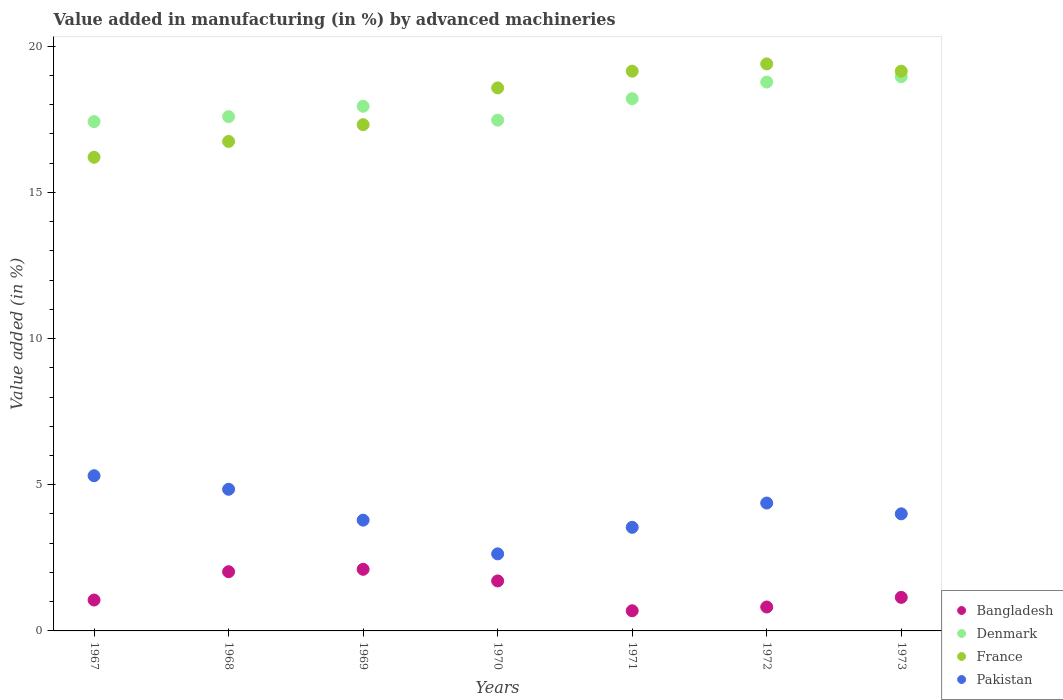How many different coloured dotlines are there?
Keep it short and to the point. 4. What is the percentage of value added in manufacturing by advanced machineries in France in 1968?
Offer a very short reply. 16.74. Across all years, what is the maximum percentage of value added in manufacturing by advanced machineries in Bangladesh?
Your response must be concise. 2.11. Across all years, what is the minimum percentage of value added in manufacturing by advanced machineries in France?
Offer a terse response. 16.2. In which year was the percentage of value added in manufacturing by advanced machineries in Bangladesh maximum?
Give a very brief answer. 1969. What is the total percentage of value added in manufacturing by advanced machineries in Pakistan in the graph?
Your response must be concise. 28.5. What is the difference between the percentage of value added in manufacturing by advanced machineries in Pakistan in 1968 and that in 1971?
Make the answer very short. 1.3. What is the difference between the percentage of value added in manufacturing by advanced machineries in Bangladesh in 1973 and the percentage of value added in manufacturing by advanced machineries in Denmark in 1971?
Your answer should be compact. -17.06. What is the average percentage of value added in manufacturing by advanced machineries in Bangladesh per year?
Your answer should be compact. 1.36. In the year 1972, what is the difference between the percentage of value added in manufacturing by advanced machineries in Bangladesh and percentage of value added in manufacturing by advanced machineries in Pakistan?
Make the answer very short. -3.56. In how many years, is the percentage of value added in manufacturing by advanced machineries in Pakistan greater than 19 %?
Your response must be concise. 0. What is the ratio of the percentage of value added in manufacturing by advanced machineries in Bangladesh in 1968 to that in 1973?
Provide a short and direct response. 1.77. Is the percentage of value added in manufacturing by advanced machineries in France in 1969 less than that in 1973?
Keep it short and to the point. Yes. What is the difference between the highest and the second highest percentage of value added in manufacturing by advanced machineries in Bangladesh?
Provide a succinct answer. 0.08. What is the difference between the highest and the lowest percentage of value added in manufacturing by advanced machineries in Denmark?
Make the answer very short. 1.54. Is the sum of the percentage of value added in manufacturing by advanced machineries in France in 1969 and 1972 greater than the maximum percentage of value added in manufacturing by advanced machineries in Bangladesh across all years?
Your answer should be very brief. Yes. Is it the case that in every year, the sum of the percentage of value added in manufacturing by advanced machineries in Denmark and percentage of value added in manufacturing by advanced machineries in France  is greater than the sum of percentage of value added in manufacturing by advanced machineries in Bangladesh and percentage of value added in manufacturing by advanced machineries in Pakistan?
Your response must be concise. Yes. Does the percentage of value added in manufacturing by advanced machineries in Denmark monotonically increase over the years?
Offer a terse response. No. Is the percentage of value added in manufacturing by advanced machineries in Denmark strictly greater than the percentage of value added in manufacturing by advanced machineries in Bangladesh over the years?
Keep it short and to the point. Yes. Is the percentage of value added in manufacturing by advanced machineries in Pakistan strictly less than the percentage of value added in manufacturing by advanced machineries in Denmark over the years?
Your response must be concise. Yes. How many years are there in the graph?
Your answer should be very brief. 7. What is the difference between two consecutive major ticks on the Y-axis?
Your response must be concise. 5. Are the values on the major ticks of Y-axis written in scientific E-notation?
Keep it short and to the point. No. Does the graph contain grids?
Offer a terse response. No. How many legend labels are there?
Offer a very short reply. 4. How are the legend labels stacked?
Offer a very short reply. Vertical. What is the title of the graph?
Offer a very short reply. Value added in manufacturing (in %) by advanced machineries. Does "Guinea-Bissau" appear as one of the legend labels in the graph?
Provide a succinct answer. No. What is the label or title of the X-axis?
Offer a terse response. Years. What is the label or title of the Y-axis?
Keep it short and to the point. Value added (in %). What is the Value added (in %) of Bangladesh in 1967?
Keep it short and to the point. 1.06. What is the Value added (in %) of Denmark in 1967?
Offer a very short reply. 17.42. What is the Value added (in %) in France in 1967?
Offer a very short reply. 16.2. What is the Value added (in %) of Pakistan in 1967?
Keep it short and to the point. 5.31. What is the Value added (in %) in Bangladesh in 1968?
Keep it short and to the point. 2.03. What is the Value added (in %) in Denmark in 1968?
Give a very brief answer. 17.59. What is the Value added (in %) in France in 1968?
Your answer should be compact. 16.74. What is the Value added (in %) in Pakistan in 1968?
Your response must be concise. 4.84. What is the Value added (in %) of Bangladesh in 1969?
Your answer should be very brief. 2.11. What is the Value added (in %) in Denmark in 1969?
Keep it short and to the point. 17.94. What is the Value added (in %) of France in 1969?
Your answer should be compact. 17.31. What is the Value added (in %) of Pakistan in 1969?
Keep it short and to the point. 3.79. What is the Value added (in %) of Bangladesh in 1970?
Your answer should be very brief. 1.71. What is the Value added (in %) of Denmark in 1970?
Provide a succinct answer. 17.47. What is the Value added (in %) of France in 1970?
Give a very brief answer. 18.57. What is the Value added (in %) in Pakistan in 1970?
Provide a short and direct response. 2.64. What is the Value added (in %) in Bangladesh in 1971?
Your answer should be compact. 0.69. What is the Value added (in %) in Denmark in 1971?
Give a very brief answer. 18.2. What is the Value added (in %) in France in 1971?
Give a very brief answer. 19.14. What is the Value added (in %) of Pakistan in 1971?
Your response must be concise. 3.54. What is the Value added (in %) of Bangladesh in 1972?
Your answer should be compact. 0.82. What is the Value added (in %) of Denmark in 1972?
Provide a short and direct response. 18.77. What is the Value added (in %) in France in 1972?
Offer a terse response. 19.39. What is the Value added (in %) of Pakistan in 1972?
Keep it short and to the point. 4.37. What is the Value added (in %) in Bangladesh in 1973?
Your answer should be compact. 1.15. What is the Value added (in %) of Denmark in 1973?
Your answer should be very brief. 18.95. What is the Value added (in %) of France in 1973?
Give a very brief answer. 19.14. What is the Value added (in %) of Pakistan in 1973?
Make the answer very short. 4. Across all years, what is the maximum Value added (in %) in Bangladesh?
Give a very brief answer. 2.11. Across all years, what is the maximum Value added (in %) of Denmark?
Offer a terse response. 18.95. Across all years, what is the maximum Value added (in %) of France?
Your answer should be very brief. 19.39. Across all years, what is the maximum Value added (in %) in Pakistan?
Keep it short and to the point. 5.31. Across all years, what is the minimum Value added (in %) of Bangladesh?
Ensure brevity in your answer.  0.69. Across all years, what is the minimum Value added (in %) in Denmark?
Offer a terse response. 17.42. Across all years, what is the minimum Value added (in %) of France?
Offer a very short reply. 16.2. Across all years, what is the minimum Value added (in %) of Pakistan?
Your answer should be compact. 2.64. What is the total Value added (in %) of Bangladesh in the graph?
Your answer should be very brief. 9.55. What is the total Value added (in %) of Denmark in the graph?
Keep it short and to the point. 126.35. What is the total Value added (in %) of France in the graph?
Your answer should be compact. 126.5. What is the total Value added (in %) of Pakistan in the graph?
Keep it short and to the point. 28.5. What is the difference between the Value added (in %) in Bangladesh in 1967 and that in 1968?
Your answer should be very brief. -0.97. What is the difference between the Value added (in %) in Denmark in 1967 and that in 1968?
Your answer should be compact. -0.17. What is the difference between the Value added (in %) in France in 1967 and that in 1968?
Your answer should be very brief. -0.54. What is the difference between the Value added (in %) in Pakistan in 1967 and that in 1968?
Offer a very short reply. 0.46. What is the difference between the Value added (in %) in Bangladesh in 1967 and that in 1969?
Your answer should be very brief. -1.05. What is the difference between the Value added (in %) of Denmark in 1967 and that in 1969?
Make the answer very short. -0.52. What is the difference between the Value added (in %) in France in 1967 and that in 1969?
Make the answer very short. -1.11. What is the difference between the Value added (in %) of Pakistan in 1967 and that in 1969?
Your answer should be very brief. 1.52. What is the difference between the Value added (in %) of Bangladesh in 1967 and that in 1970?
Your answer should be very brief. -0.65. What is the difference between the Value added (in %) of Denmark in 1967 and that in 1970?
Ensure brevity in your answer.  -0.05. What is the difference between the Value added (in %) of France in 1967 and that in 1970?
Your answer should be compact. -2.37. What is the difference between the Value added (in %) of Pakistan in 1967 and that in 1970?
Ensure brevity in your answer.  2.67. What is the difference between the Value added (in %) in Bangladesh in 1967 and that in 1971?
Make the answer very short. 0.37. What is the difference between the Value added (in %) of Denmark in 1967 and that in 1971?
Make the answer very short. -0.78. What is the difference between the Value added (in %) of France in 1967 and that in 1971?
Your answer should be compact. -2.94. What is the difference between the Value added (in %) in Pakistan in 1967 and that in 1971?
Offer a very short reply. 1.77. What is the difference between the Value added (in %) of Bangladesh in 1967 and that in 1972?
Provide a succinct answer. 0.24. What is the difference between the Value added (in %) of Denmark in 1967 and that in 1972?
Ensure brevity in your answer.  -1.35. What is the difference between the Value added (in %) in France in 1967 and that in 1972?
Ensure brevity in your answer.  -3.19. What is the difference between the Value added (in %) in Pakistan in 1967 and that in 1972?
Ensure brevity in your answer.  0.93. What is the difference between the Value added (in %) in Bangladesh in 1967 and that in 1973?
Your answer should be compact. -0.09. What is the difference between the Value added (in %) of Denmark in 1967 and that in 1973?
Offer a very short reply. -1.54. What is the difference between the Value added (in %) in France in 1967 and that in 1973?
Provide a succinct answer. -2.94. What is the difference between the Value added (in %) in Pakistan in 1967 and that in 1973?
Keep it short and to the point. 1.3. What is the difference between the Value added (in %) of Bangladesh in 1968 and that in 1969?
Your answer should be very brief. -0.08. What is the difference between the Value added (in %) of Denmark in 1968 and that in 1969?
Your answer should be compact. -0.35. What is the difference between the Value added (in %) of France in 1968 and that in 1969?
Give a very brief answer. -0.57. What is the difference between the Value added (in %) in Pakistan in 1968 and that in 1969?
Make the answer very short. 1.06. What is the difference between the Value added (in %) of Bangladesh in 1968 and that in 1970?
Provide a short and direct response. 0.32. What is the difference between the Value added (in %) in Denmark in 1968 and that in 1970?
Your answer should be compact. 0.12. What is the difference between the Value added (in %) of France in 1968 and that in 1970?
Your answer should be very brief. -1.83. What is the difference between the Value added (in %) in Pakistan in 1968 and that in 1970?
Provide a succinct answer. 2.21. What is the difference between the Value added (in %) in Bangladesh in 1968 and that in 1971?
Your answer should be compact. 1.34. What is the difference between the Value added (in %) of Denmark in 1968 and that in 1971?
Provide a short and direct response. -0.61. What is the difference between the Value added (in %) of France in 1968 and that in 1971?
Offer a very short reply. -2.4. What is the difference between the Value added (in %) of Pakistan in 1968 and that in 1971?
Your response must be concise. 1.3. What is the difference between the Value added (in %) in Bangladesh in 1968 and that in 1972?
Your response must be concise. 1.21. What is the difference between the Value added (in %) in Denmark in 1968 and that in 1972?
Your answer should be compact. -1.18. What is the difference between the Value added (in %) of France in 1968 and that in 1972?
Your response must be concise. -2.65. What is the difference between the Value added (in %) of Pakistan in 1968 and that in 1972?
Your answer should be compact. 0.47. What is the difference between the Value added (in %) of Bangladesh in 1968 and that in 1973?
Your answer should be very brief. 0.88. What is the difference between the Value added (in %) in Denmark in 1968 and that in 1973?
Your answer should be very brief. -1.37. What is the difference between the Value added (in %) of France in 1968 and that in 1973?
Provide a short and direct response. -2.4. What is the difference between the Value added (in %) in Pakistan in 1968 and that in 1973?
Your response must be concise. 0.84. What is the difference between the Value added (in %) in Bangladesh in 1969 and that in 1970?
Your response must be concise. 0.4. What is the difference between the Value added (in %) of Denmark in 1969 and that in 1970?
Provide a succinct answer. 0.47. What is the difference between the Value added (in %) in France in 1969 and that in 1970?
Ensure brevity in your answer.  -1.26. What is the difference between the Value added (in %) in Pakistan in 1969 and that in 1970?
Your answer should be compact. 1.15. What is the difference between the Value added (in %) of Bangladesh in 1969 and that in 1971?
Make the answer very short. 1.42. What is the difference between the Value added (in %) of Denmark in 1969 and that in 1971?
Your response must be concise. -0.26. What is the difference between the Value added (in %) in France in 1969 and that in 1971?
Your answer should be very brief. -1.83. What is the difference between the Value added (in %) of Pakistan in 1969 and that in 1971?
Offer a terse response. 0.25. What is the difference between the Value added (in %) in Bangladesh in 1969 and that in 1972?
Your answer should be compact. 1.29. What is the difference between the Value added (in %) in Denmark in 1969 and that in 1972?
Your answer should be very brief. -0.83. What is the difference between the Value added (in %) in France in 1969 and that in 1972?
Your answer should be compact. -2.08. What is the difference between the Value added (in %) of Pakistan in 1969 and that in 1972?
Your response must be concise. -0.58. What is the difference between the Value added (in %) of Bangladesh in 1969 and that in 1973?
Offer a very short reply. 0.96. What is the difference between the Value added (in %) in Denmark in 1969 and that in 1973?
Provide a short and direct response. -1.01. What is the difference between the Value added (in %) in France in 1969 and that in 1973?
Your response must be concise. -1.83. What is the difference between the Value added (in %) of Pakistan in 1969 and that in 1973?
Keep it short and to the point. -0.22. What is the difference between the Value added (in %) of Bangladesh in 1970 and that in 1971?
Ensure brevity in your answer.  1.02. What is the difference between the Value added (in %) of Denmark in 1970 and that in 1971?
Make the answer very short. -0.73. What is the difference between the Value added (in %) in France in 1970 and that in 1971?
Keep it short and to the point. -0.57. What is the difference between the Value added (in %) of Pakistan in 1970 and that in 1971?
Offer a very short reply. -0.91. What is the difference between the Value added (in %) of Bangladesh in 1970 and that in 1972?
Offer a terse response. 0.89. What is the difference between the Value added (in %) in Denmark in 1970 and that in 1972?
Your answer should be very brief. -1.3. What is the difference between the Value added (in %) in France in 1970 and that in 1972?
Ensure brevity in your answer.  -0.82. What is the difference between the Value added (in %) in Pakistan in 1970 and that in 1972?
Make the answer very short. -1.74. What is the difference between the Value added (in %) of Bangladesh in 1970 and that in 1973?
Provide a short and direct response. 0.56. What is the difference between the Value added (in %) of Denmark in 1970 and that in 1973?
Offer a very short reply. -1.48. What is the difference between the Value added (in %) in France in 1970 and that in 1973?
Give a very brief answer. -0.57. What is the difference between the Value added (in %) in Pakistan in 1970 and that in 1973?
Your response must be concise. -1.37. What is the difference between the Value added (in %) in Bangladesh in 1971 and that in 1972?
Make the answer very short. -0.13. What is the difference between the Value added (in %) of Denmark in 1971 and that in 1972?
Provide a short and direct response. -0.57. What is the difference between the Value added (in %) of France in 1971 and that in 1972?
Offer a very short reply. -0.25. What is the difference between the Value added (in %) of Pakistan in 1971 and that in 1972?
Provide a succinct answer. -0.83. What is the difference between the Value added (in %) of Bangladesh in 1971 and that in 1973?
Keep it short and to the point. -0.46. What is the difference between the Value added (in %) in Denmark in 1971 and that in 1973?
Offer a very short reply. -0.75. What is the difference between the Value added (in %) of France in 1971 and that in 1973?
Keep it short and to the point. -0. What is the difference between the Value added (in %) in Pakistan in 1971 and that in 1973?
Provide a succinct answer. -0.46. What is the difference between the Value added (in %) in Bangladesh in 1972 and that in 1973?
Provide a short and direct response. -0.33. What is the difference between the Value added (in %) in Denmark in 1972 and that in 1973?
Your answer should be very brief. -0.18. What is the difference between the Value added (in %) in France in 1972 and that in 1973?
Offer a terse response. 0.25. What is the difference between the Value added (in %) of Pakistan in 1972 and that in 1973?
Provide a succinct answer. 0.37. What is the difference between the Value added (in %) of Bangladesh in 1967 and the Value added (in %) of Denmark in 1968?
Your answer should be compact. -16.53. What is the difference between the Value added (in %) of Bangladesh in 1967 and the Value added (in %) of France in 1968?
Give a very brief answer. -15.68. What is the difference between the Value added (in %) in Bangladesh in 1967 and the Value added (in %) in Pakistan in 1968?
Your answer should be very brief. -3.79. What is the difference between the Value added (in %) in Denmark in 1967 and the Value added (in %) in France in 1968?
Keep it short and to the point. 0.68. What is the difference between the Value added (in %) of Denmark in 1967 and the Value added (in %) of Pakistan in 1968?
Ensure brevity in your answer.  12.57. What is the difference between the Value added (in %) of France in 1967 and the Value added (in %) of Pakistan in 1968?
Your response must be concise. 11.35. What is the difference between the Value added (in %) of Bangladesh in 1967 and the Value added (in %) of Denmark in 1969?
Ensure brevity in your answer.  -16.89. What is the difference between the Value added (in %) of Bangladesh in 1967 and the Value added (in %) of France in 1969?
Give a very brief answer. -16.26. What is the difference between the Value added (in %) in Bangladesh in 1967 and the Value added (in %) in Pakistan in 1969?
Provide a short and direct response. -2.73. What is the difference between the Value added (in %) in Denmark in 1967 and the Value added (in %) in France in 1969?
Provide a succinct answer. 0.1. What is the difference between the Value added (in %) in Denmark in 1967 and the Value added (in %) in Pakistan in 1969?
Your response must be concise. 13.63. What is the difference between the Value added (in %) in France in 1967 and the Value added (in %) in Pakistan in 1969?
Your response must be concise. 12.41. What is the difference between the Value added (in %) of Bangladesh in 1967 and the Value added (in %) of Denmark in 1970?
Ensure brevity in your answer.  -16.41. What is the difference between the Value added (in %) of Bangladesh in 1967 and the Value added (in %) of France in 1970?
Keep it short and to the point. -17.51. What is the difference between the Value added (in %) of Bangladesh in 1967 and the Value added (in %) of Pakistan in 1970?
Your answer should be compact. -1.58. What is the difference between the Value added (in %) of Denmark in 1967 and the Value added (in %) of France in 1970?
Your response must be concise. -1.15. What is the difference between the Value added (in %) in Denmark in 1967 and the Value added (in %) in Pakistan in 1970?
Your response must be concise. 14.78. What is the difference between the Value added (in %) of France in 1967 and the Value added (in %) of Pakistan in 1970?
Provide a short and direct response. 13.56. What is the difference between the Value added (in %) of Bangladesh in 1967 and the Value added (in %) of Denmark in 1971?
Provide a short and direct response. -17.15. What is the difference between the Value added (in %) in Bangladesh in 1967 and the Value added (in %) in France in 1971?
Your answer should be very brief. -18.09. What is the difference between the Value added (in %) in Bangladesh in 1967 and the Value added (in %) in Pakistan in 1971?
Offer a very short reply. -2.49. What is the difference between the Value added (in %) of Denmark in 1967 and the Value added (in %) of France in 1971?
Keep it short and to the point. -1.72. What is the difference between the Value added (in %) in Denmark in 1967 and the Value added (in %) in Pakistan in 1971?
Keep it short and to the point. 13.88. What is the difference between the Value added (in %) of France in 1967 and the Value added (in %) of Pakistan in 1971?
Your answer should be compact. 12.66. What is the difference between the Value added (in %) of Bangladesh in 1967 and the Value added (in %) of Denmark in 1972?
Your answer should be very brief. -17.71. What is the difference between the Value added (in %) of Bangladesh in 1967 and the Value added (in %) of France in 1972?
Make the answer very short. -18.34. What is the difference between the Value added (in %) in Bangladesh in 1967 and the Value added (in %) in Pakistan in 1972?
Offer a terse response. -3.32. What is the difference between the Value added (in %) in Denmark in 1967 and the Value added (in %) in France in 1972?
Keep it short and to the point. -1.97. What is the difference between the Value added (in %) of Denmark in 1967 and the Value added (in %) of Pakistan in 1972?
Your answer should be very brief. 13.05. What is the difference between the Value added (in %) of France in 1967 and the Value added (in %) of Pakistan in 1972?
Give a very brief answer. 11.83. What is the difference between the Value added (in %) in Bangladesh in 1967 and the Value added (in %) in Denmark in 1973?
Offer a very short reply. -17.9. What is the difference between the Value added (in %) of Bangladesh in 1967 and the Value added (in %) of France in 1973?
Your response must be concise. -18.09. What is the difference between the Value added (in %) in Bangladesh in 1967 and the Value added (in %) in Pakistan in 1973?
Make the answer very short. -2.95. What is the difference between the Value added (in %) of Denmark in 1967 and the Value added (in %) of France in 1973?
Provide a succinct answer. -1.72. What is the difference between the Value added (in %) of Denmark in 1967 and the Value added (in %) of Pakistan in 1973?
Your response must be concise. 13.41. What is the difference between the Value added (in %) in France in 1967 and the Value added (in %) in Pakistan in 1973?
Ensure brevity in your answer.  12.19. What is the difference between the Value added (in %) in Bangladesh in 1968 and the Value added (in %) in Denmark in 1969?
Keep it short and to the point. -15.92. What is the difference between the Value added (in %) in Bangladesh in 1968 and the Value added (in %) in France in 1969?
Offer a terse response. -15.29. What is the difference between the Value added (in %) in Bangladesh in 1968 and the Value added (in %) in Pakistan in 1969?
Give a very brief answer. -1.76. What is the difference between the Value added (in %) of Denmark in 1968 and the Value added (in %) of France in 1969?
Your answer should be compact. 0.27. What is the difference between the Value added (in %) in Denmark in 1968 and the Value added (in %) in Pakistan in 1969?
Your response must be concise. 13.8. What is the difference between the Value added (in %) in France in 1968 and the Value added (in %) in Pakistan in 1969?
Provide a short and direct response. 12.95. What is the difference between the Value added (in %) in Bangladesh in 1968 and the Value added (in %) in Denmark in 1970?
Give a very brief answer. -15.44. What is the difference between the Value added (in %) in Bangladesh in 1968 and the Value added (in %) in France in 1970?
Your answer should be compact. -16.55. What is the difference between the Value added (in %) in Bangladesh in 1968 and the Value added (in %) in Pakistan in 1970?
Your response must be concise. -0.61. What is the difference between the Value added (in %) in Denmark in 1968 and the Value added (in %) in France in 1970?
Provide a succinct answer. -0.98. What is the difference between the Value added (in %) in Denmark in 1968 and the Value added (in %) in Pakistan in 1970?
Provide a succinct answer. 14.95. What is the difference between the Value added (in %) of France in 1968 and the Value added (in %) of Pakistan in 1970?
Provide a short and direct response. 14.11. What is the difference between the Value added (in %) in Bangladesh in 1968 and the Value added (in %) in Denmark in 1971?
Your answer should be very brief. -16.18. What is the difference between the Value added (in %) in Bangladesh in 1968 and the Value added (in %) in France in 1971?
Provide a succinct answer. -17.12. What is the difference between the Value added (in %) in Bangladesh in 1968 and the Value added (in %) in Pakistan in 1971?
Provide a succinct answer. -1.52. What is the difference between the Value added (in %) in Denmark in 1968 and the Value added (in %) in France in 1971?
Keep it short and to the point. -1.56. What is the difference between the Value added (in %) of Denmark in 1968 and the Value added (in %) of Pakistan in 1971?
Your answer should be very brief. 14.05. What is the difference between the Value added (in %) in France in 1968 and the Value added (in %) in Pakistan in 1971?
Your answer should be very brief. 13.2. What is the difference between the Value added (in %) in Bangladesh in 1968 and the Value added (in %) in Denmark in 1972?
Give a very brief answer. -16.75. What is the difference between the Value added (in %) in Bangladesh in 1968 and the Value added (in %) in France in 1972?
Keep it short and to the point. -17.37. What is the difference between the Value added (in %) in Bangladesh in 1968 and the Value added (in %) in Pakistan in 1972?
Your answer should be very brief. -2.35. What is the difference between the Value added (in %) of Denmark in 1968 and the Value added (in %) of France in 1972?
Offer a very short reply. -1.8. What is the difference between the Value added (in %) of Denmark in 1968 and the Value added (in %) of Pakistan in 1972?
Provide a short and direct response. 13.21. What is the difference between the Value added (in %) of France in 1968 and the Value added (in %) of Pakistan in 1972?
Provide a succinct answer. 12.37. What is the difference between the Value added (in %) in Bangladesh in 1968 and the Value added (in %) in Denmark in 1973?
Make the answer very short. -16.93. What is the difference between the Value added (in %) in Bangladesh in 1968 and the Value added (in %) in France in 1973?
Your answer should be compact. -17.12. What is the difference between the Value added (in %) of Bangladesh in 1968 and the Value added (in %) of Pakistan in 1973?
Your response must be concise. -1.98. What is the difference between the Value added (in %) of Denmark in 1968 and the Value added (in %) of France in 1973?
Your answer should be very brief. -1.56. What is the difference between the Value added (in %) of Denmark in 1968 and the Value added (in %) of Pakistan in 1973?
Provide a succinct answer. 13.58. What is the difference between the Value added (in %) in France in 1968 and the Value added (in %) in Pakistan in 1973?
Ensure brevity in your answer.  12.74. What is the difference between the Value added (in %) in Bangladesh in 1969 and the Value added (in %) in Denmark in 1970?
Provide a short and direct response. -15.36. What is the difference between the Value added (in %) in Bangladesh in 1969 and the Value added (in %) in France in 1970?
Provide a succinct answer. -16.46. What is the difference between the Value added (in %) in Bangladesh in 1969 and the Value added (in %) in Pakistan in 1970?
Your answer should be very brief. -0.53. What is the difference between the Value added (in %) of Denmark in 1969 and the Value added (in %) of France in 1970?
Offer a very short reply. -0.63. What is the difference between the Value added (in %) of Denmark in 1969 and the Value added (in %) of Pakistan in 1970?
Provide a short and direct response. 15.31. What is the difference between the Value added (in %) in France in 1969 and the Value added (in %) in Pakistan in 1970?
Offer a very short reply. 14.68. What is the difference between the Value added (in %) of Bangladesh in 1969 and the Value added (in %) of Denmark in 1971?
Offer a terse response. -16.1. What is the difference between the Value added (in %) in Bangladesh in 1969 and the Value added (in %) in France in 1971?
Ensure brevity in your answer.  -17.04. What is the difference between the Value added (in %) of Bangladesh in 1969 and the Value added (in %) of Pakistan in 1971?
Give a very brief answer. -1.44. What is the difference between the Value added (in %) in Denmark in 1969 and the Value added (in %) in France in 1971?
Offer a terse response. -1.2. What is the difference between the Value added (in %) in Denmark in 1969 and the Value added (in %) in Pakistan in 1971?
Give a very brief answer. 14.4. What is the difference between the Value added (in %) in France in 1969 and the Value added (in %) in Pakistan in 1971?
Your answer should be compact. 13.77. What is the difference between the Value added (in %) of Bangladesh in 1969 and the Value added (in %) of Denmark in 1972?
Keep it short and to the point. -16.66. What is the difference between the Value added (in %) in Bangladesh in 1969 and the Value added (in %) in France in 1972?
Make the answer very short. -17.28. What is the difference between the Value added (in %) in Bangladesh in 1969 and the Value added (in %) in Pakistan in 1972?
Your response must be concise. -2.27. What is the difference between the Value added (in %) in Denmark in 1969 and the Value added (in %) in France in 1972?
Your answer should be very brief. -1.45. What is the difference between the Value added (in %) of Denmark in 1969 and the Value added (in %) of Pakistan in 1972?
Your response must be concise. 13.57. What is the difference between the Value added (in %) in France in 1969 and the Value added (in %) in Pakistan in 1972?
Your answer should be compact. 12.94. What is the difference between the Value added (in %) in Bangladesh in 1969 and the Value added (in %) in Denmark in 1973?
Provide a short and direct response. -16.85. What is the difference between the Value added (in %) of Bangladesh in 1969 and the Value added (in %) of France in 1973?
Provide a succinct answer. -17.04. What is the difference between the Value added (in %) in Bangladesh in 1969 and the Value added (in %) in Pakistan in 1973?
Provide a succinct answer. -1.9. What is the difference between the Value added (in %) of Denmark in 1969 and the Value added (in %) of France in 1973?
Ensure brevity in your answer.  -1.2. What is the difference between the Value added (in %) of Denmark in 1969 and the Value added (in %) of Pakistan in 1973?
Keep it short and to the point. 13.94. What is the difference between the Value added (in %) of France in 1969 and the Value added (in %) of Pakistan in 1973?
Your answer should be compact. 13.31. What is the difference between the Value added (in %) of Bangladesh in 1970 and the Value added (in %) of Denmark in 1971?
Make the answer very short. -16.49. What is the difference between the Value added (in %) of Bangladesh in 1970 and the Value added (in %) of France in 1971?
Keep it short and to the point. -17.43. What is the difference between the Value added (in %) in Bangladesh in 1970 and the Value added (in %) in Pakistan in 1971?
Your answer should be very brief. -1.83. What is the difference between the Value added (in %) of Denmark in 1970 and the Value added (in %) of France in 1971?
Provide a succinct answer. -1.67. What is the difference between the Value added (in %) in Denmark in 1970 and the Value added (in %) in Pakistan in 1971?
Keep it short and to the point. 13.93. What is the difference between the Value added (in %) in France in 1970 and the Value added (in %) in Pakistan in 1971?
Make the answer very short. 15.03. What is the difference between the Value added (in %) of Bangladesh in 1970 and the Value added (in %) of Denmark in 1972?
Offer a terse response. -17.06. What is the difference between the Value added (in %) in Bangladesh in 1970 and the Value added (in %) in France in 1972?
Your response must be concise. -17.68. What is the difference between the Value added (in %) of Bangladesh in 1970 and the Value added (in %) of Pakistan in 1972?
Make the answer very short. -2.66. What is the difference between the Value added (in %) in Denmark in 1970 and the Value added (in %) in France in 1972?
Provide a short and direct response. -1.92. What is the difference between the Value added (in %) of Denmark in 1970 and the Value added (in %) of Pakistan in 1972?
Your answer should be compact. 13.1. What is the difference between the Value added (in %) of France in 1970 and the Value added (in %) of Pakistan in 1972?
Keep it short and to the point. 14.2. What is the difference between the Value added (in %) in Bangladesh in 1970 and the Value added (in %) in Denmark in 1973?
Keep it short and to the point. -17.24. What is the difference between the Value added (in %) in Bangladesh in 1970 and the Value added (in %) in France in 1973?
Offer a terse response. -17.43. What is the difference between the Value added (in %) of Bangladesh in 1970 and the Value added (in %) of Pakistan in 1973?
Provide a short and direct response. -2.29. What is the difference between the Value added (in %) of Denmark in 1970 and the Value added (in %) of France in 1973?
Keep it short and to the point. -1.67. What is the difference between the Value added (in %) of Denmark in 1970 and the Value added (in %) of Pakistan in 1973?
Ensure brevity in your answer.  13.46. What is the difference between the Value added (in %) of France in 1970 and the Value added (in %) of Pakistan in 1973?
Provide a short and direct response. 14.57. What is the difference between the Value added (in %) of Bangladesh in 1971 and the Value added (in %) of Denmark in 1972?
Ensure brevity in your answer.  -18.08. What is the difference between the Value added (in %) in Bangladesh in 1971 and the Value added (in %) in France in 1972?
Give a very brief answer. -18.7. What is the difference between the Value added (in %) of Bangladesh in 1971 and the Value added (in %) of Pakistan in 1972?
Offer a terse response. -3.68. What is the difference between the Value added (in %) of Denmark in 1971 and the Value added (in %) of France in 1972?
Provide a short and direct response. -1.19. What is the difference between the Value added (in %) in Denmark in 1971 and the Value added (in %) in Pakistan in 1972?
Provide a succinct answer. 13.83. What is the difference between the Value added (in %) in France in 1971 and the Value added (in %) in Pakistan in 1972?
Offer a very short reply. 14.77. What is the difference between the Value added (in %) of Bangladesh in 1971 and the Value added (in %) of Denmark in 1973?
Keep it short and to the point. -18.27. What is the difference between the Value added (in %) in Bangladesh in 1971 and the Value added (in %) in France in 1973?
Your response must be concise. -18.45. What is the difference between the Value added (in %) in Bangladesh in 1971 and the Value added (in %) in Pakistan in 1973?
Provide a short and direct response. -3.32. What is the difference between the Value added (in %) in Denmark in 1971 and the Value added (in %) in France in 1973?
Keep it short and to the point. -0.94. What is the difference between the Value added (in %) of Denmark in 1971 and the Value added (in %) of Pakistan in 1973?
Provide a short and direct response. 14.2. What is the difference between the Value added (in %) of France in 1971 and the Value added (in %) of Pakistan in 1973?
Offer a terse response. 15.14. What is the difference between the Value added (in %) in Bangladesh in 1972 and the Value added (in %) in Denmark in 1973?
Keep it short and to the point. -18.14. What is the difference between the Value added (in %) in Bangladesh in 1972 and the Value added (in %) in France in 1973?
Your answer should be very brief. -18.33. What is the difference between the Value added (in %) of Bangladesh in 1972 and the Value added (in %) of Pakistan in 1973?
Provide a short and direct response. -3.19. What is the difference between the Value added (in %) of Denmark in 1972 and the Value added (in %) of France in 1973?
Provide a short and direct response. -0.37. What is the difference between the Value added (in %) in Denmark in 1972 and the Value added (in %) in Pakistan in 1973?
Keep it short and to the point. 14.77. What is the difference between the Value added (in %) of France in 1972 and the Value added (in %) of Pakistan in 1973?
Your answer should be very brief. 15.39. What is the average Value added (in %) in Bangladesh per year?
Your answer should be very brief. 1.36. What is the average Value added (in %) of Denmark per year?
Provide a succinct answer. 18.05. What is the average Value added (in %) in France per year?
Your answer should be very brief. 18.07. What is the average Value added (in %) of Pakistan per year?
Provide a short and direct response. 4.07. In the year 1967, what is the difference between the Value added (in %) of Bangladesh and Value added (in %) of Denmark?
Keep it short and to the point. -16.36. In the year 1967, what is the difference between the Value added (in %) of Bangladesh and Value added (in %) of France?
Keep it short and to the point. -15.14. In the year 1967, what is the difference between the Value added (in %) of Bangladesh and Value added (in %) of Pakistan?
Offer a very short reply. -4.25. In the year 1967, what is the difference between the Value added (in %) in Denmark and Value added (in %) in France?
Give a very brief answer. 1.22. In the year 1967, what is the difference between the Value added (in %) of Denmark and Value added (in %) of Pakistan?
Your response must be concise. 12.11. In the year 1967, what is the difference between the Value added (in %) in France and Value added (in %) in Pakistan?
Ensure brevity in your answer.  10.89. In the year 1968, what is the difference between the Value added (in %) in Bangladesh and Value added (in %) in Denmark?
Offer a very short reply. -15.56. In the year 1968, what is the difference between the Value added (in %) of Bangladesh and Value added (in %) of France?
Give a very brief answer. -14.72. In the year 1968, what is the difference between the Value added (in %) of Bangladesh and Value added (in %) of Pakistan?
Provide a succinct answer. -2.82. In the year 1968, what is the difference between the Value added (in %) in Denmark and Value added (in %) in France?
Make the answer very short. 0.85. In the year 1968, what is the difference between the Value added (in %) in Denmark and Value added (in %) in Pakistan?
Make the answer very short. 12.74. In the year 1968, what is the difference between the Value added (in %) in France and Value added (in %) in Pakistan?
Offer a very short reply. 11.9. In the year 1969, what is the difference between the Value added (in %) of Bangladesh and Value added (in %) of Denmark?
Provide a short and direct response. -15.84. In the year 1969, what is the difference between the Value added (in %) in Bangladesh and Value added (in %) in France?
Provide a short and direct response. -15.21. In the year 1969, what is the difference between the Value added (in %) in Bangladesh and Value added (in %) in Pakistan?
Your answer should be compact. -1.68. In the year 1969, what is the difference between the Value added (in %) in Denmark and Value added (in %) in France?
Give a very brief answer. 0.63. In the year 1969, what is the difference between the Value added (in %) of Denmark and Value added (in %) of Pakistan?
Offer a very short reply. 14.15. In the year 1969, what is the difference between the Value added (in %) of France and Value added (in %) of Pakistan?
Offer a terse response. 13.53. In the year 1970, what is the difference between the Value added (in %) of Bangladesh and Value added (in %) of Denmark?
Your response must be concise. -15.76. In the year 1970, what is the difference between the Value added (in %) of Bangladesh and Value added (in %) of France?
Your answer should be very brief. -16.86. In the year 1970, what is the difference between the Value added (in %) in Bangladesh and Value added (in %) in Pakistan?
Ensure brevity in your answer.  -0.93. In the year 1970, what is the difference between the Value added (in %) in Denmark and Value added (in %) in France?
Make the answer very short. -1.1. In the year 1970, what is the difference between the Value added (in %) in Denmark and Value added (in %) in Pakistan?
Keep it short and to the point. 14.83. In the year 1970, what is the difference between the Value added (in %) in France and Value added (in %) in Pakistan?
Offer a terse response. 15.94. In the year 1971, what is the difference between the Value added (in %) in Bangladesh and Value added (in %) in Denmark?
Give a very brief answer. -17.51. In the year 1971, what is the difference between the Value added (in %) in Bangladesh and Value added (in %) in France?
Ensure brevity in your answer.  -18.45. In the year 1971, what is the difference between the Value added (in %) in Bangladesh and Value added (in %) in Pakistan?
Your response must be concise. -2.85. In the year 1971, what is the difference between the Value added (in %) of Denmark and Value added (in %) of France?
Your answer should be very brief. -0.94. In the year 1971, what is the difference between the Value added (in %) in Denmark and Value added (in %) in Pakistan?
Offer a very short reply. 14.66. In the year 1971, what is the difference between the Value added (in %) of France and Value added (in %) of Pakistan?
Offer a very short reply. 15.6. In the year 1972, what is the difference between the Value added (in %) of Bangladesh and Value added (in %) of Denmark?
Offer a very short reply. -17.95. In the year 1972, what is the difference between the Value added (in %) of Bangladesh and Value added (in %) of France?
Your answer should be compact. -18.57. In the year 1972, what is the difference between the Value added (in %) of Bangladesh and Value added (in %) of Pakistan?
Offer a terse response. -3.56. In the year 1972, what is the difference between the Value added (in %) in Denmark and Value added (in %) in France?
Keep it short and to the point. -0.62. In the year 1972, what is the difference between the Value added (in %) in Denmark and Value added (in %) in Pakistan?
Provide a succinct answer. 14.4. In the year 1972, what is the difference between the Value added (in %) of France and Value added (in %) of Pakistan?
Keep it short and to the point. 15.02. In the year 1973, what is the difference between the Value added (in %) of Bangladesh and Value added (in %) of Denmark?
Provide a short and direct response. -17.81. In the year 1973, what is the difference between the Value added (in %) in Bangladesh and Value added (in %) in France?
Your answer should be very brief. -18. In the year 1973, what is the difference between the Value added (in %) in Bangladesh and Value added (in %) in Pakistan?
Your answer should be compact. -2.86. In the year 1973, what is the difference between the Value added (in %) in Denmark and Value added (in %) in France?
Make the answer very short. -0.19. In the year 1973, what is the difference between the Value added (in %) in Denmark and Value added (in %) in Pakistan?
Ensure brevity in your answer.  14.95. In the year 1973, what is the difference between the Value added (in %) in France and Value added (in %) in Pakistan?
Offer a very short reply. 15.14. What is the ratio of the Value added (in %) in Bangladesh in 1967 to that in 1968?
Ensure brevity in your answer.  0.52. What is the ratio of the Value added (in %) in France in 1967 to that in 1968?
Ensure brevity in your answer.  0.97. What is the ratio of the Value added (in %) of Pakistan in 1967 to that in 1968?
Your response must be concise. 1.1. What is the ratio of the Value added (in %) in Bangladesh in 1967 to that in 1969?
Provide a short and direct response. 0.5. What is the ratio of the Value added (in %) of Denmark in 1967 to that in 1969?
Keep it short and to the point. 0.97. What is the ratio of the Value added (in %) in France in 1967 to that in 1969?
Keep it short and to the point. 0.94. What is the ratio of the Value added (in %) in Pakistan in 1967 to that in 1969?
Provide a succinct answer. 1.4. What is the ratio of the Value added (in %) in Bangladesh in 1967 to that in 1970?
Offer a very short reply. 0.62. What is the ratio of the Value added (in %) of Denmark in 1967 to that in 1970?
Your answer should be very brief. 1. What is the ratio of the Value added (in %) in France in 1967 to that in 1970?
Provide a succinct answer. 0.87. What is the ratio of the Value added (in %) of Pakistan in 1967 to that in 1970?
Your answer should be very brief. 2.01. What is the ratio of the Value added (in %) of Bangladesh in 1967 to that in 1971?
Provide a short and direct response. 1.53. What is the ratio of the Value added (in %) in Denmark in 1967 to that in 1971?
Provide a succinct answer. 0.96. What is the ratio of the Value added (in %) of France in 1967 to that in 1971?
Provide a short and direct response. 0.85. What is the ratio of the Value added (in %) in Pakistan in 1967 to that in 1971?
Provide a short and direct response. 1.5. What is the ratio of the Value added (in %) in Bangladesh in 1967 to that in 1972?
Your response must be concise. 1.29. What is the ratio of the Value added (in %) in Denmark in 1967 to that in 1972?
Offer a terse response. 0.93. What is the ratio of the Value added (in %) of France in 1967 to that in 1972?
Ensure brevity in your answer.  0.84. What is the ratio of the Value added (in %) in Pakistan in 1967 to that in 1972?
Provide a succinct answer. 1.21. What is the ratio of the Value added (in %) of Bangladesh in 1967 to that in 1973?
Provide a succinct answer. 0.92. What is the ratio of the Value added (in %) in Denmark in 1967 to that in 1973?
Offer a terse response. 0.92. What is the ratio of the Value added (in %) of France in 1967 to that in 1973?
Provide a short and direct response. 0.85. What is the ratio of the Value added (in %) in Pakistan in 1967 to that in 1973?
Your answer should be compact. 1.33. What is the ratio of the Value added (in %) in Bangladesh in 1968 to that in 1969?
Provide a short and direct response. 0.96. What is the ratio of the Value added (in %) of Denmark in 1968 to that in 1969?
Provide a short and direct response. 0.98. What is the ratio of the Value added (in %) in France in 1968 to that in 1969?
Provide a short and direct response. 0.97. What is the ratio of the Value added (in %) in Pakistan in 1968 to that in 1969?
Your answer should be very brief. 1.28. What is the ratio of the Value added (in %) of Bangladesh in 1968 to that in 1970?
Give a very brief answer. 1.18. What is the ratio of the Value added (in %) in Denmark in 1968 to that in 1970?
Offer a very short reply. 1.01. What is the ratio of the Value added (in %) in France in 1968 to that in 1970?
Provide a succinct answer. 0.9. What is the ratio of the Value added (in %) of Pakistan in 1968 to that in 1970?
Offer a very short reply. 1.84. What is the ratio of the Value added (in %) in Bangladesh in 1968 to that in 1971?
Make the answer very short. 2.94. What is the ratio of the Value added (in %) in Denmark in 1968 to that in 1971?
Make the answer very short. 0.97. What is the ratio of the Value added (in %) of France in 1968 to that in 1971?
Provide a succinct answer. 0.87. What is the ratio of the Value added (in %) in Pakistan in 1968 to that in 1971?
Provide a short and direct response. 1.37. What is the ratio of the Value added (in %) of Bangladesh in 1968 to that in 1972?
Provide a short and direct response. 2.48. What is the ratio of the Value added (in %) in Denmark in 1968 to that in 1972?
Make the answer very short. 0.94. What is the ratio of the Value added (in %) in France in 1968 to that in 1972?
Provide a succinct answer. 0.86. What is the ratio of the Value added (in %) of Pakistan in 1968 to that in 1972?
Offer a very short reply. 1.11. What is the ratio of the Value added (in %) of Bangladesh in 1968 to that in 1973?
Provide a succinct answer. 1.77. What is the ratio of the Value added (in %) of Denmark in 1968 to that in 1973?
Provide a short and direct response. 0.93. What is the ratio of the Value added (in %) of France in 1968 to that in 1973?
Provide a succinct answer. 0.87. What is the ratio of the Value added (in %) of Pakistan in 1968 to that in 1973?
Keep it short and to the point. 1.21. What is the ratio of the Value added (in %) in Bangladesh in 1969 to that in 1970?
Offer a very short reply. 1.23. What is the ratio of the Value added (in %) in Denmark in 1969 to that in 1970?
Your answer should be compact. 1.03. What is the ratio of the Value added (in %) of France in 1969 to that in 1970?
Provide a succinct answer. 0.93. What is the ratio of the Value added (in %) in Pakistan in 1969 to that in 1970?
Make the answer very short. 1.44. What is the ratio of the Value added (in %) in Bangladesh in 1969 to that in 1971?
Your answer should be compact. 3.06. What is the ratio of the Value added (in %) of Denmark in 1969 to that in 1971?
Provide a succinct answer. 0.99. What is the ratio of the Value added (in %) of France in 1969 to that in 1971?
Keep it short and to the point. 0.9. What is the ratio of the Value added (in %) of Pakistan in 1969 to that in 1971?
Offer a terse response. 1.07. What is the ratio of the Value added (in %) in Bangladesh in 1969 to that in 1972?
Offer a very short reply. 2.58. What is the ratio of the Value added (in %) of Denmark in 1969 to that in 1972?
Provide a succinct answer. 0.96. What is the ratio of the Value added (in %) in France in 1969 to that in 1972?
Offer a very short reply. 0.89. What is the ratio of the Value added (in %) in Pakistan in 1969 to that in 1972?
Your answer should be very brief. 0.87. What is the ratio of the Value added (in %) of Bangladesh in 1969 to that in 1973?
Your answer should be very brief. 1.84. What is the ratio of the Value added (in %) of Denmark in 1969 to that in 1973?
Provide a succinct answer. 0.95. What is the ratio of the Value added (in %) of France in 1969 to that in 1973?
Offer a very short reply. 0.9. What is the ratio of the Value added (in %) of Pakistan in 1969 to that in 1973?
Your answer should be very brief. 0.95. What is the ratio of the Value added (in %) in Bangladesh in 1970 to that in 1971?
Provide a short and direct response. 2.48. What is the ratio of the Value added (in %) of Denmark in 1970 to that in 1971?
Ensure brevity in your answer.  0.96. What is the ratio of the Value added (in %) of France in 1970 to that in 1971?
Give a very brief answer. 0.97. What is the ratio of the Value added (in %) of Pakistan in 1970 to that in 1971?
Offer a very short reply. 0.74. What is the ratio of the Value added (in %) of Bangladesh in 1970 to that in 1972?
Ensure brevity in your answer.  2.09. What is the ratio of the Value added (in %) in Denmark in 1970 to that in 1972?
Provide a short and direct response. 0.93. What is the ratio of the Value added (in %) in France in 1970 to that in 1972?
Your response must be concise. 0.96. What is the ratio of the Value added (in %) of Pakistan in 1970 to that in 1972?
Your answer should be compact. 0.6. What is the ratio of the Value added (in %) in Bangladesh in 1970 to that in 1973?
Make the answer very short. 1.49. What is the ratio of the Value added (in %) of Denmark in 1970 to that in 1973?
Provide a short and direct response. 0.92. What is the ratio of the Value added (in %) of France in 1970 to that in 1973?
Offer a terse response. 0.97. What is the ratio of the Value added (in %) of Pakistan in 1970 to that in 1973?
Offer a terse response. 0.66. What is the ratio of the Value added (in %) in Bangladesh in 1971 to that in 1972?
Make the answer very short. 0.84. What is the ratio of the Value added (in %) of Denmark in 1971 to that in 1972?
Your answer should be very brief. 0.97. What is the ratio of the Value added (in %) of France in 1971 to that in 1972?
Your response must be concise. 0.99. What is the ratio of the Value added (in %) of Pakistan in 1971 to that in 1972?
Your answer should be compact. 0.81. What is the ratio of the Value added (in %) in Bangladesh in 1971 to that in 1973?
Your response must be concise. 0.6. What is the ratio of the Value added (in %) in Denmark in 1971 to that in 1973?
Your answer should be very brief. 0.96. What is the ratio of the Value added (in %) in Pakistan in 1971 to that in 1973?
Keep it short and to the point. 0.88. What is the ratio of the Value added (in %) of Bangladesh in 1972 to that in 1973?
Ensure brevity in your answer.  0.71. What is the ratio of the Value added (in %) in Denmark in 1972 to that in 1973?
Give a very brief answer. 0.99. What is the ratio of the Value added (in %) in Pakistan in 1972 to that in 1973?
Make the answer very short. 1.09. What is the difference between the highest and the second highest Value added (in %) in Bangladesh?
Provide a succinct answer. 0.08. What is the difference between the highest and the second highest Value added (in %) in Denmark?
Provide a succinct answer. 0.18. What is the difference between the highest and the second highest Value added (in %) in France?
Your answer should be very brief. 0.25. What is the difference between the highest and the second highest Value added (in %) of Pakistan?
Offer a terse response. 0.46. What is the difference between the highest and the lowest Value added (in %) in Bangladesh?
Offer a terse response. 1.42. What is the difference between the highest and the lowest Value added (in %) in Denmark?
Ensure brevity in your answer.  1.54. What is the difference between the highest and the lowest Value added (in %) in France?
Give a very brief answer. 3.19. What is the difference between the highest and the lowest Value added (in %) of Pakistan?
Provide a succinct answer. 2.67. 